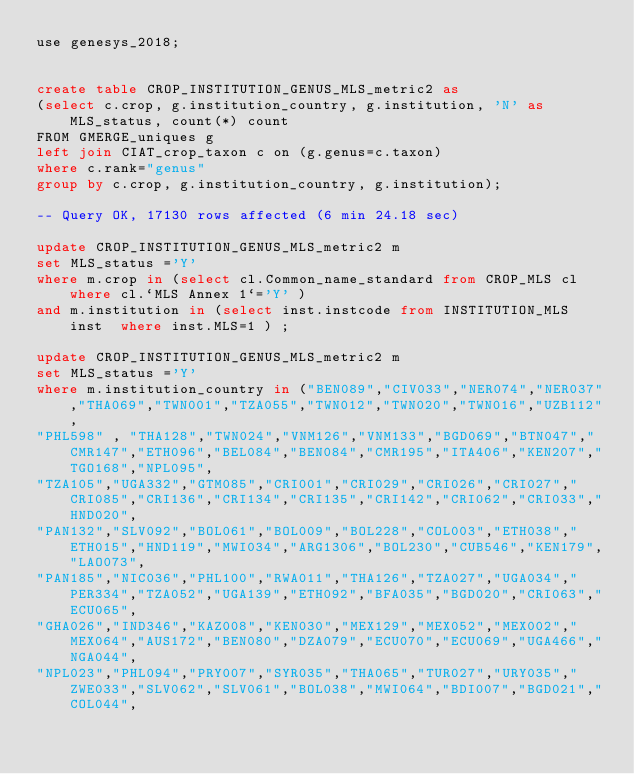Convert code to text. <code><loc_0><loc_0><loc_500><loc_500><_SQL_>use genesys_2018;


create table CROP_INSTITUTION_GENUS_MLS_metric2 as 
(select c.crop, g.institution_country, g.institution, 'N' as MLS_status, count(*) count
FROM GMERGE_uniques g
left join CIAT_crop_taxon c on (g.genus=c.taxon)
where c.rank="genus"
group by c.crop, g.institution_country, g.institution);

-- Query OK, 17130 rows affected (6 min 24.18 sec)

update CROP_INSTITUTION_GENUS_MLS_metric2 m
set MLS_status ='Y'
where m.crop in (select cl.Common_name_standard from CROP_MLS cl where cl.`MLS Annex 1`='Y' ) 
and m.institution in (select inst.instcode from INSTITUTION_MLS inst  where inst.MLS=1 ) ;

update CROP_INSTITUTION_GENUS_MLS_metric2 m
set MLS_status ='Y'
where m.institution_country in ("BEN089","CIV033","NER074","NER037","THA069","TWN001","TZA055","TWN012","TWN020","TWN016","UZB112",
"PHL598" , "THA128","TWN024","VNM126","VNM133","BGD069","BTN047","CMR147","ETH096","BEL084","BEN084","CMR195","ITA406","KEN207","TGO168","NPL095",
"TZA105","UGA332","GTM085","CRI001","CRI029","CRI026","CRI027","CRI085","CRI136","CRI134","CRI135","CRI142","CRI062","CRI033","HND020",
"PAN132","SLV092","BOL061","BOL009","BOL228","COL003","ETH038","ETH015","HND119","MWI034","ARG1306","BOL230","CUB546","KEN179","LAO073",
"PAN185","NIC036","PHL100","RWA011","THA126","TZA027","UGA034","PER334","TZA052","UGA139","ETH092","BFA035","BGD020","CRI063","ECU065",
"GHA026","IND346","KAZ008","KEN030","MEX129","MEX052","MEX002","MEX064","AUS172","BEN080","DZA079","ECU070","ECU069","UGA466","NGA044",
"NPL023","PHL094","PRY007","SYR035","THA065","TUR027","URY035","ZWE033","SLV062","SLV061","BOL038","MWI064","BDI007","BGD021","COL044",</code> 